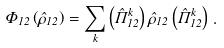Convert formula to latex. <formula><loc_0><loc_0><loc_500><loc_500>\Phi _ { 1 2 } \left ( \hat { \rho } _ { 1 2 } \right ) = \sum _ { k } \left ( \hat { \Pi } _ { 1 2 } ^ { k } \right ) \hat { \rho } _ { 1 2 } \left ( \hat { \Pi } _ { 1 2 } ^ { k } \right ) \, .</formula> 